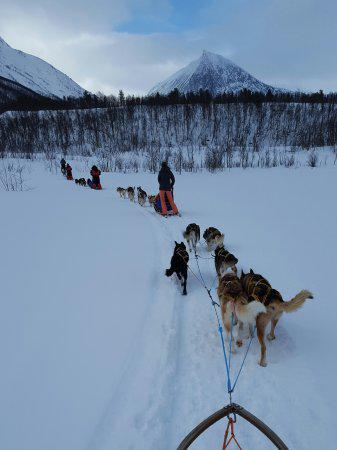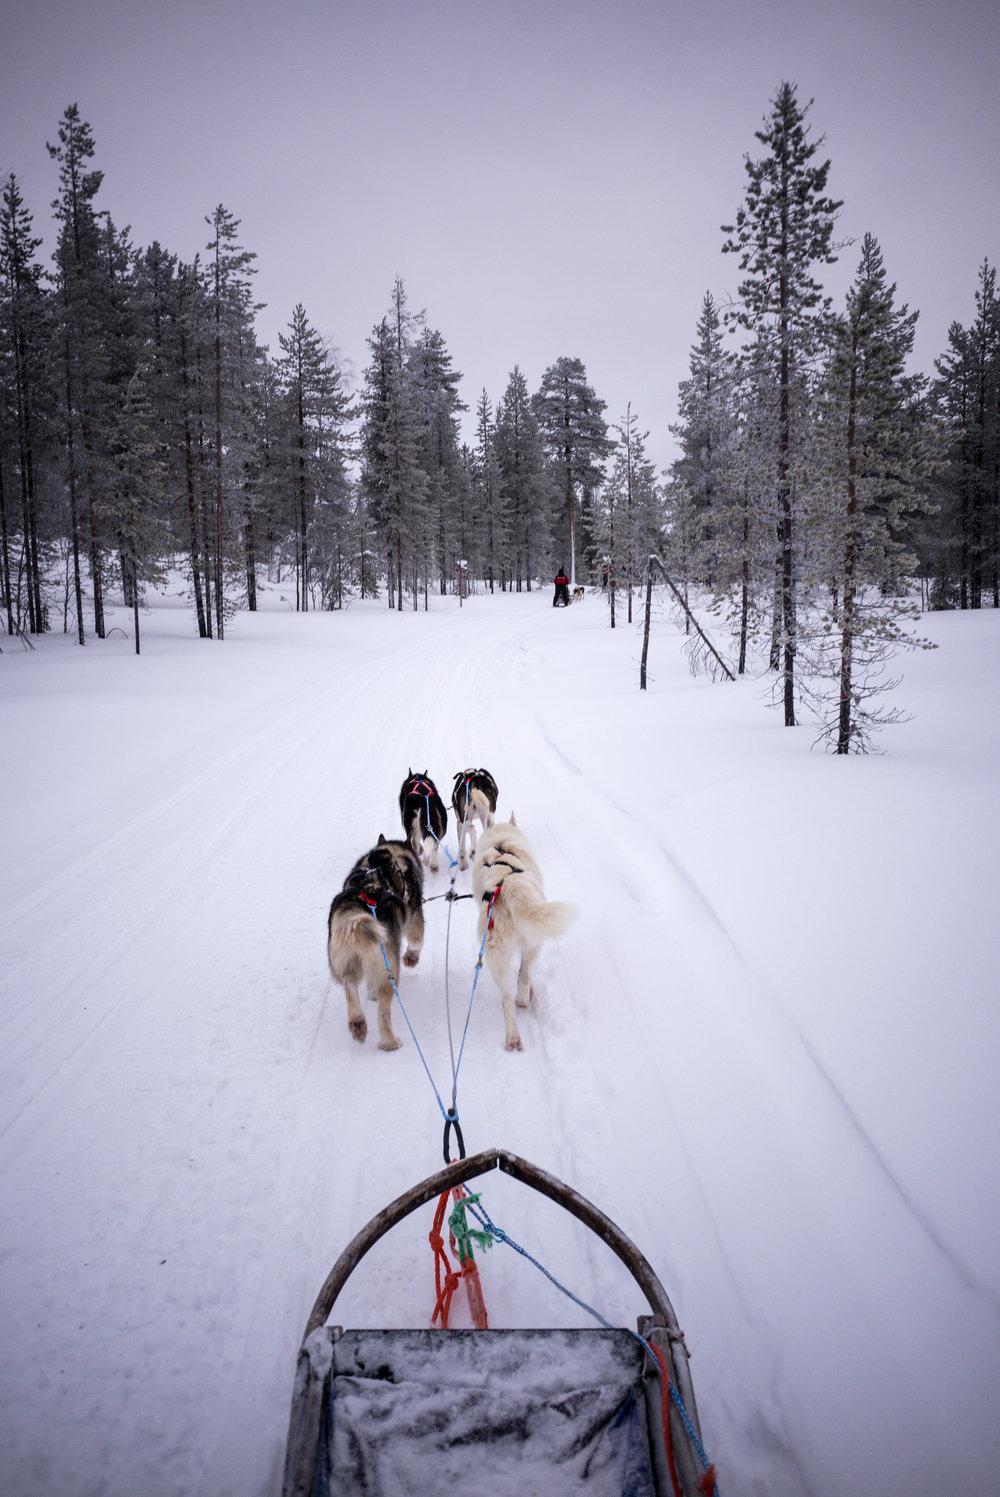The first image is the image on the left, the second image is the image on the right. Evaluate the accuracy of this statement regarding the images: "There are trees lining the trail in the image on the right". Is it true? Answer yes or no. Yes. 